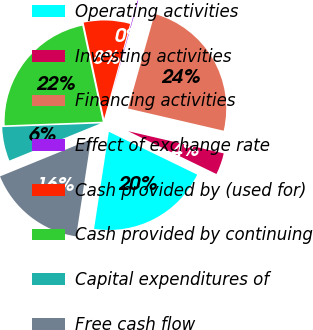Convert chart to OTSL. <chart><loc_0><loc_0><loc_500><loc_500><pie_chart><fcel>Operating activities<fcel>Investing activities<fcel>Financing activities<fcel>Effect of exchange rate<fcel>Cash provided by (used for)<fcel>Cash provided by continuing<fcel>Capital expenditures of<fcel>Free cash flow<nl><fcel>20.22%<fcel>3.55%<fcel>24.27%<fcel>0.11%<fcel>7.6%<fcel>22.24%<fcel>5.57%<fcel>16.43%<nl></chart> 